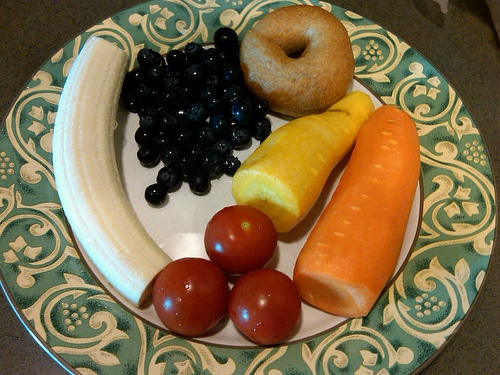Describe the objects in this image and their specific colors. I can see dining table in black, darkgreen, maroon, and tan tones, carrot in black, red, orange, and maroon tones, banana in black, lightblue, and tan tones, donut in black, olive, tan, and maroon tones, and carrot in black, orange, olive, and khaki tones in this image. 